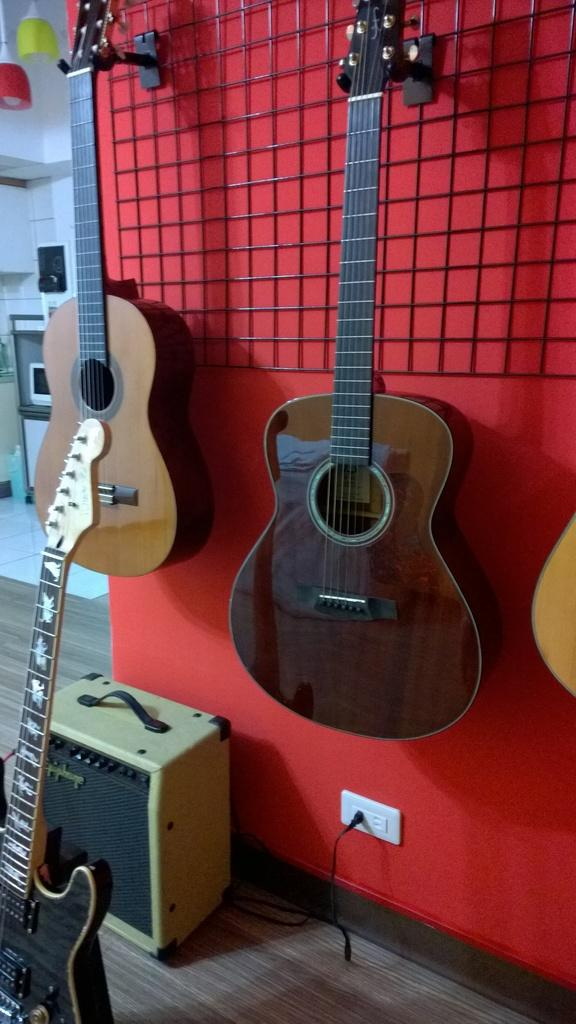What type of musical instruments are in the image? There are guitars in the image. What surface can be seen beneath the guitars? There is a floor visible in the image. What electronic device is present in the image? There is a monitor in the image. Can you see a snake slithering across the floor in the image? There is no snake present in the image; only guitars, a floor, and a monitor are visible. 